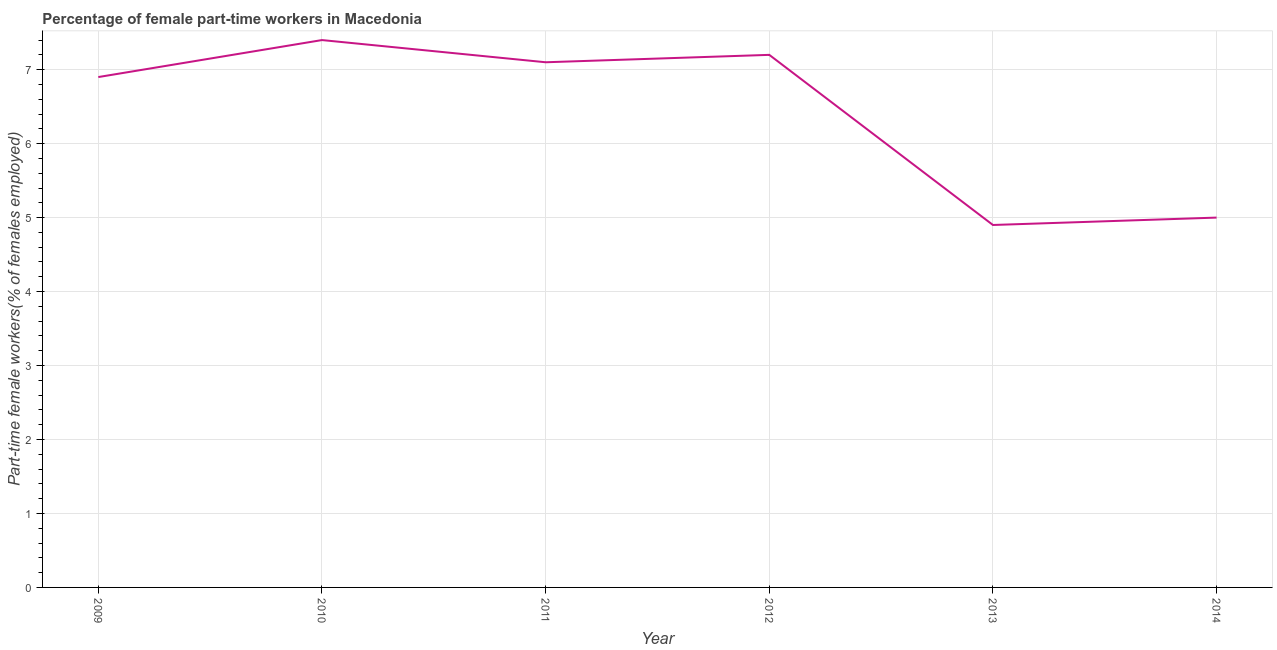What is the percentage of part-time female workers in 2011?
Offer a very short reply. 7.1. Across all years, what is the maximum percentage of part-time female workers?
Offer a very short reply. 7.4. Across all years, what is the minimum percentage of part-time female workers?
Your answer should be very brief. 4.9. In which year was the percentage of part-time female workers maximum?
Make the answer very short. 2010. In which year was the percentage of part-time female workers minimum?
Make the answer very short. 2013. What is the sum of the percentage of part-time female workers?
Keep it short and to the point. 38.5. What is the difference between the percentage of part-time female workers in 2009 and 2010?
Make the answer very short. -0.5. What is the average percentage of part-time female workers per year?
Keep it short and to the point. 6.42. What is the median percentage of part-time female workers?
Your response must be concise. 7. In how many years, is the percentage of part-time female workers greater than 1 %?
Provide a succinct answer. 6. Do a majority of the years between 2010 and 2011 (inclusive) have percentage of part-time female workers greater than 6.8 %?
Provide a succinct answer. Yes. What is the ratio of the percentage of part-time female workers in 2012 to that in 2014?
Offer a very short reply. 1.44. Is the percentage of part-time female workers in 2009 less than that in 2011?
Your answer should be very brief. Yes. What is the difference between the highest and the second highest percentage of part-time female workers?
Offer a very short reply. 0.2. Is the sum of the percentage of part-time female workers in 2009 and 2012 greater than the maximum percentage of part-time female workers across all years?
Give a very brief answer. Yes. What is the difference between the highest and the lowest percentage of part-time female workers?
Offer a very short reply. 2.5. In how many years, is the percentage of part-time female workers greater than the average percentage of part-time female workers taken over all years?
Your response must be concise. 4. Does the percentage of part-time female workers monotonically increase over the years?
Your response must be concise. No. How many years are there in the graph?
Your response must be concise. 6. Does the graph contain any zero values?
Keep it short and to the point. No. What is the title of the graph?
Provide a succinct answer. Percentage of female part-time workers in Macedonia. What is the label or title of the X-axis?
Keep it short and to the point. Year. What is the label or title of the Y-axis?
Give a very brief answer. Part-time female workers(% of females employed). What is the Part-time female workers(% of females employed) in 2009?
Keep it short and to the point. 6.9. What is the Part-time female workers(% of females employed) in 2010?
Your answer should be compact. 7.4. What is the Part-time female workers(% of females employed) in 2011?
Make the answer very short. 7.1. What is the Part-time female workers(% of females employed) of 2012?
Make the answer very short. 7.2. What is the Part-time female workers(% of females employed) of 2013?
Your response must be concise. 4.9. What is the difference between the Part-time female workers(% of females employed) in 2009 and 2011?
Your answer should be very brief. -0.2. What is the difference between the Part-time female workers(% of females employed) in 2009 and 2012?
Your response must be concise. -0.3. What is the difference between the Part-time female workers(% of females employed) in 2009 and 2013?
Your response must be concise. 2. What is the difference between the Part-time female workers(% of females employed) in 2011 and 2012?
Offer a terse response. -0.1. What is the difference between the Part-time female workers(% of females employed) in 2012 and 2014?
Make the answer very short. 2.2. What is the ratio of the Part-time female workers(% of females employed) in 2009 to that in 2010?
Provide a short and direct response. 0.93. What is the ratio of the Part-time female workers(% of females employed) in 2009 to that in 2012?
Your answer should be compact. 0.96. What is the ratio of the Part-time female workers(% of females employed) in 2009 to that in 2013?
Your answer should be very brief. 1.41. What is the ratio of the Part-time female workers(% of females employed) in 2009 to that in 2014?
Provide a succinct answer. 1.38. What is the ratio of the Part-time female workers(% of females employed) in 2010 to that in 2011?
Your response must be concise. 1.04. What is the ratio of the Part-time female workers(% of females employed) in 2010 to that in 2012?
Ensure brevity in your answer.  1.03. What is the ratio of the Part-time female workers(% of females employed) in 2010 to that in 2013?
Your answer should be very brief. 1.51. What is the ratio of the Part-time female workers(% of females employed) in 2010 to that in 2014?
Ensure brevity in your answer.  1.48. What is the ratio of the Part-time female workers(% of females employed) in 2011 to that in 2012?
Ensure brevity in your answer.  0.99. What is the ratio of the Part-time female workers(% of females employed) in 2011 to that in 2013?
Your answer should be very brief. 1.45. What is the ratio of the Part-time female workers(% of females employed) in 2011 to that in 2014?
Provide a short and direct response. 1.42. What is the ratio of the Part-time female workers(% of females employed) in 2012 to that in 2013?
Provide a succinct answer. 1.47. What is the ratio of the Part-time female workers(% of females employed) in 2012 to that in 2014?
Your answer should be compact. 1.44. 